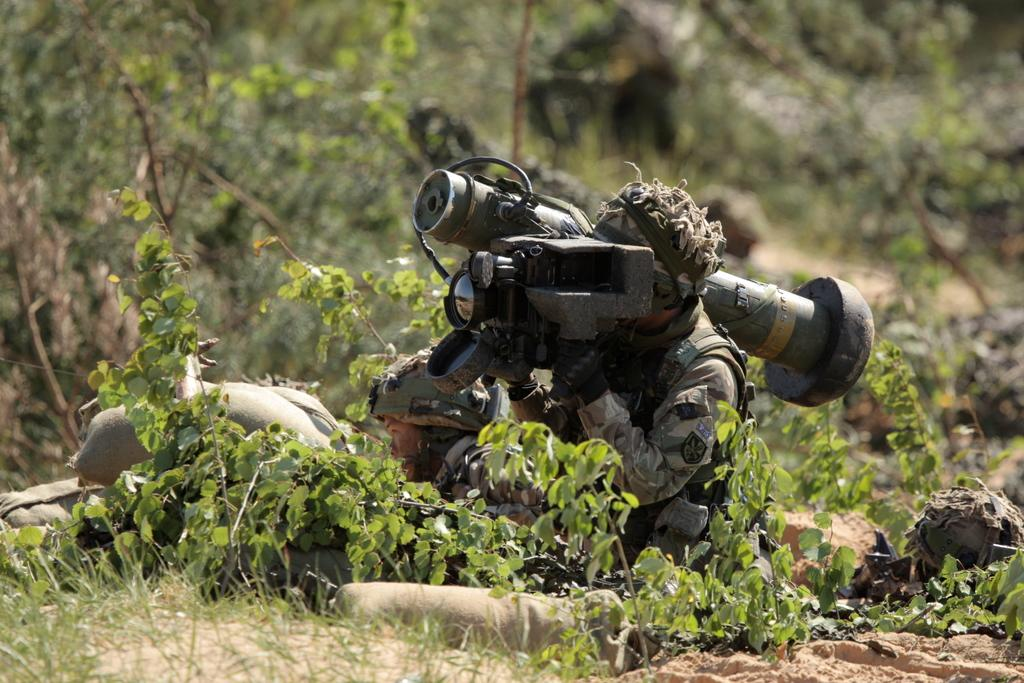How many soldiers are present in the image? There are two soldiers in the image. What type of vegetation can be seen in the image? There are green plants and trees in the image. What type of loaf is being carried by the soldiers in the image? There is no loaf present in the image; the soldiers are not carrying any such item. 